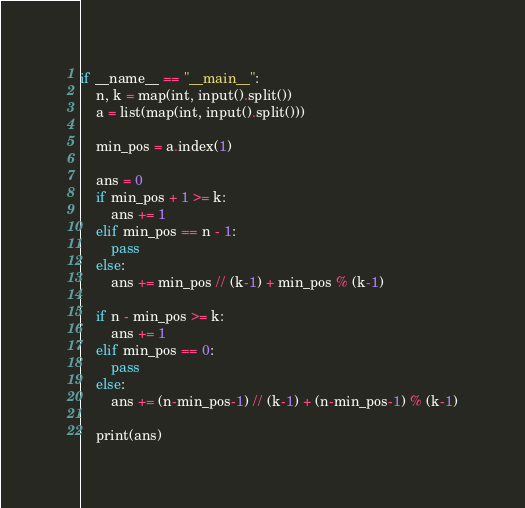Convert code to text. <code><loc_0><loc_0><loc_500><loc_500><_Python_>if __name__ == "__main__":
    n, k = map(int, input().split())
    a = list(map(int, input().split()))

    min_pos = a.index(1)

    ans = 0
    if min_pos + 1 >= k:
        ans += 1
    elif min_pos == n - 1:
        pass
    else:
        ans += min_pos // (k-1) + min_pos % (k-1)

    if n - min_pos >= k:
        ans += 1
    elif min_pos == 0:
        pass
    else:
        ans += (n-min_pos-1) // (k-1) + (n-min_pos-1) % (k-1)

    print(ans)
</code> 